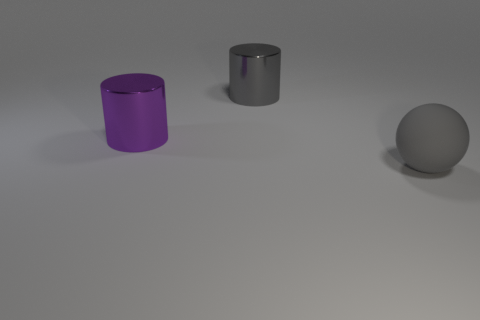There is a cylinder behind the large purple metallic cylinder; how big is it? The cylinder behind the large purple metallic cylinder is smaller in size. Its exact dimensions cannot be determined from the image, but relative to the larger cylinder, it appears to be about half the height and similar in diameter. 